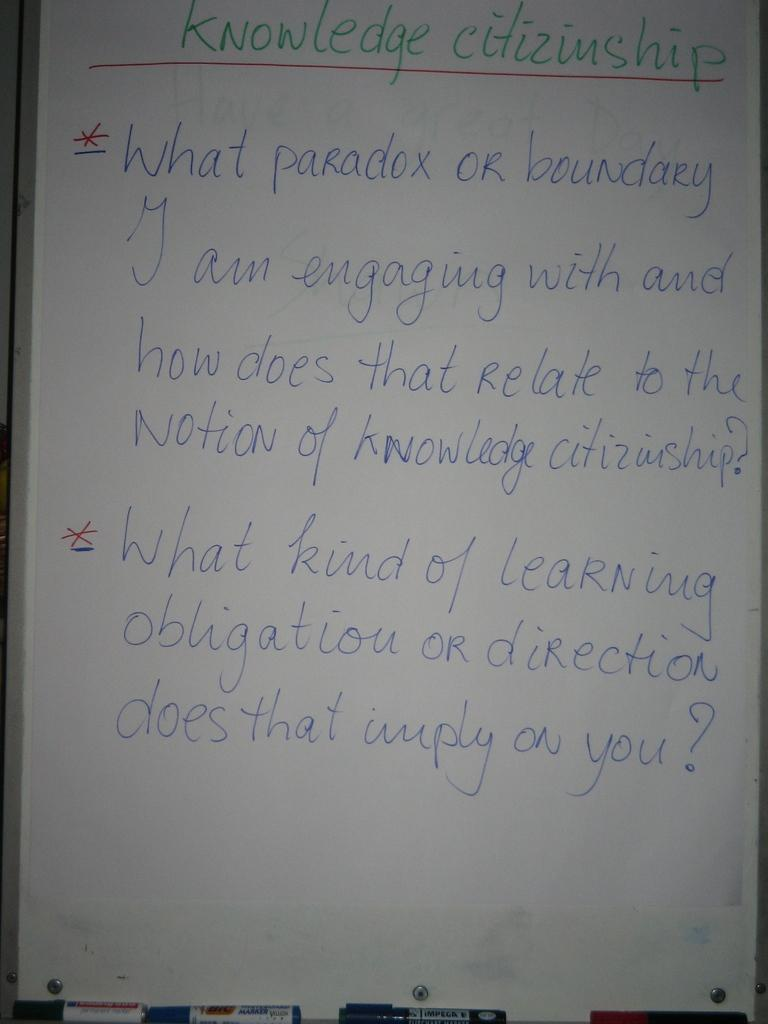Provide a one-sentence caption for the provided image. A white board discussion on Knowledge Citizinship written in green, red, and blue markers. 